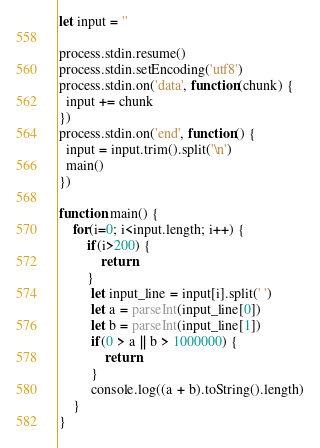Convert code to text. <code><loc_0><loc_0><loc_500><loc_500><_JavaScript_>let input = ''

process.stdin.resume()
process.stdin.setEncoding('utf8')
process.stdin.on('data', function(chunk) {
  input += chunk
})
process.stdin.on('end', function() {
  input = input.trim().split('\n')
  main()
})

function main() {
    for(i=0; i<input.length; i++) {
        if(i>200) {
            return
        }
         let input_line = input[i].split(' ')
         let a = parseInt(input_line[0])
         let b = parseInt(input_line[1])
         if(0 > a || b > 1000000) {
             return
         }
         console.log((a + b).toString().length)
    }
}
</code> 